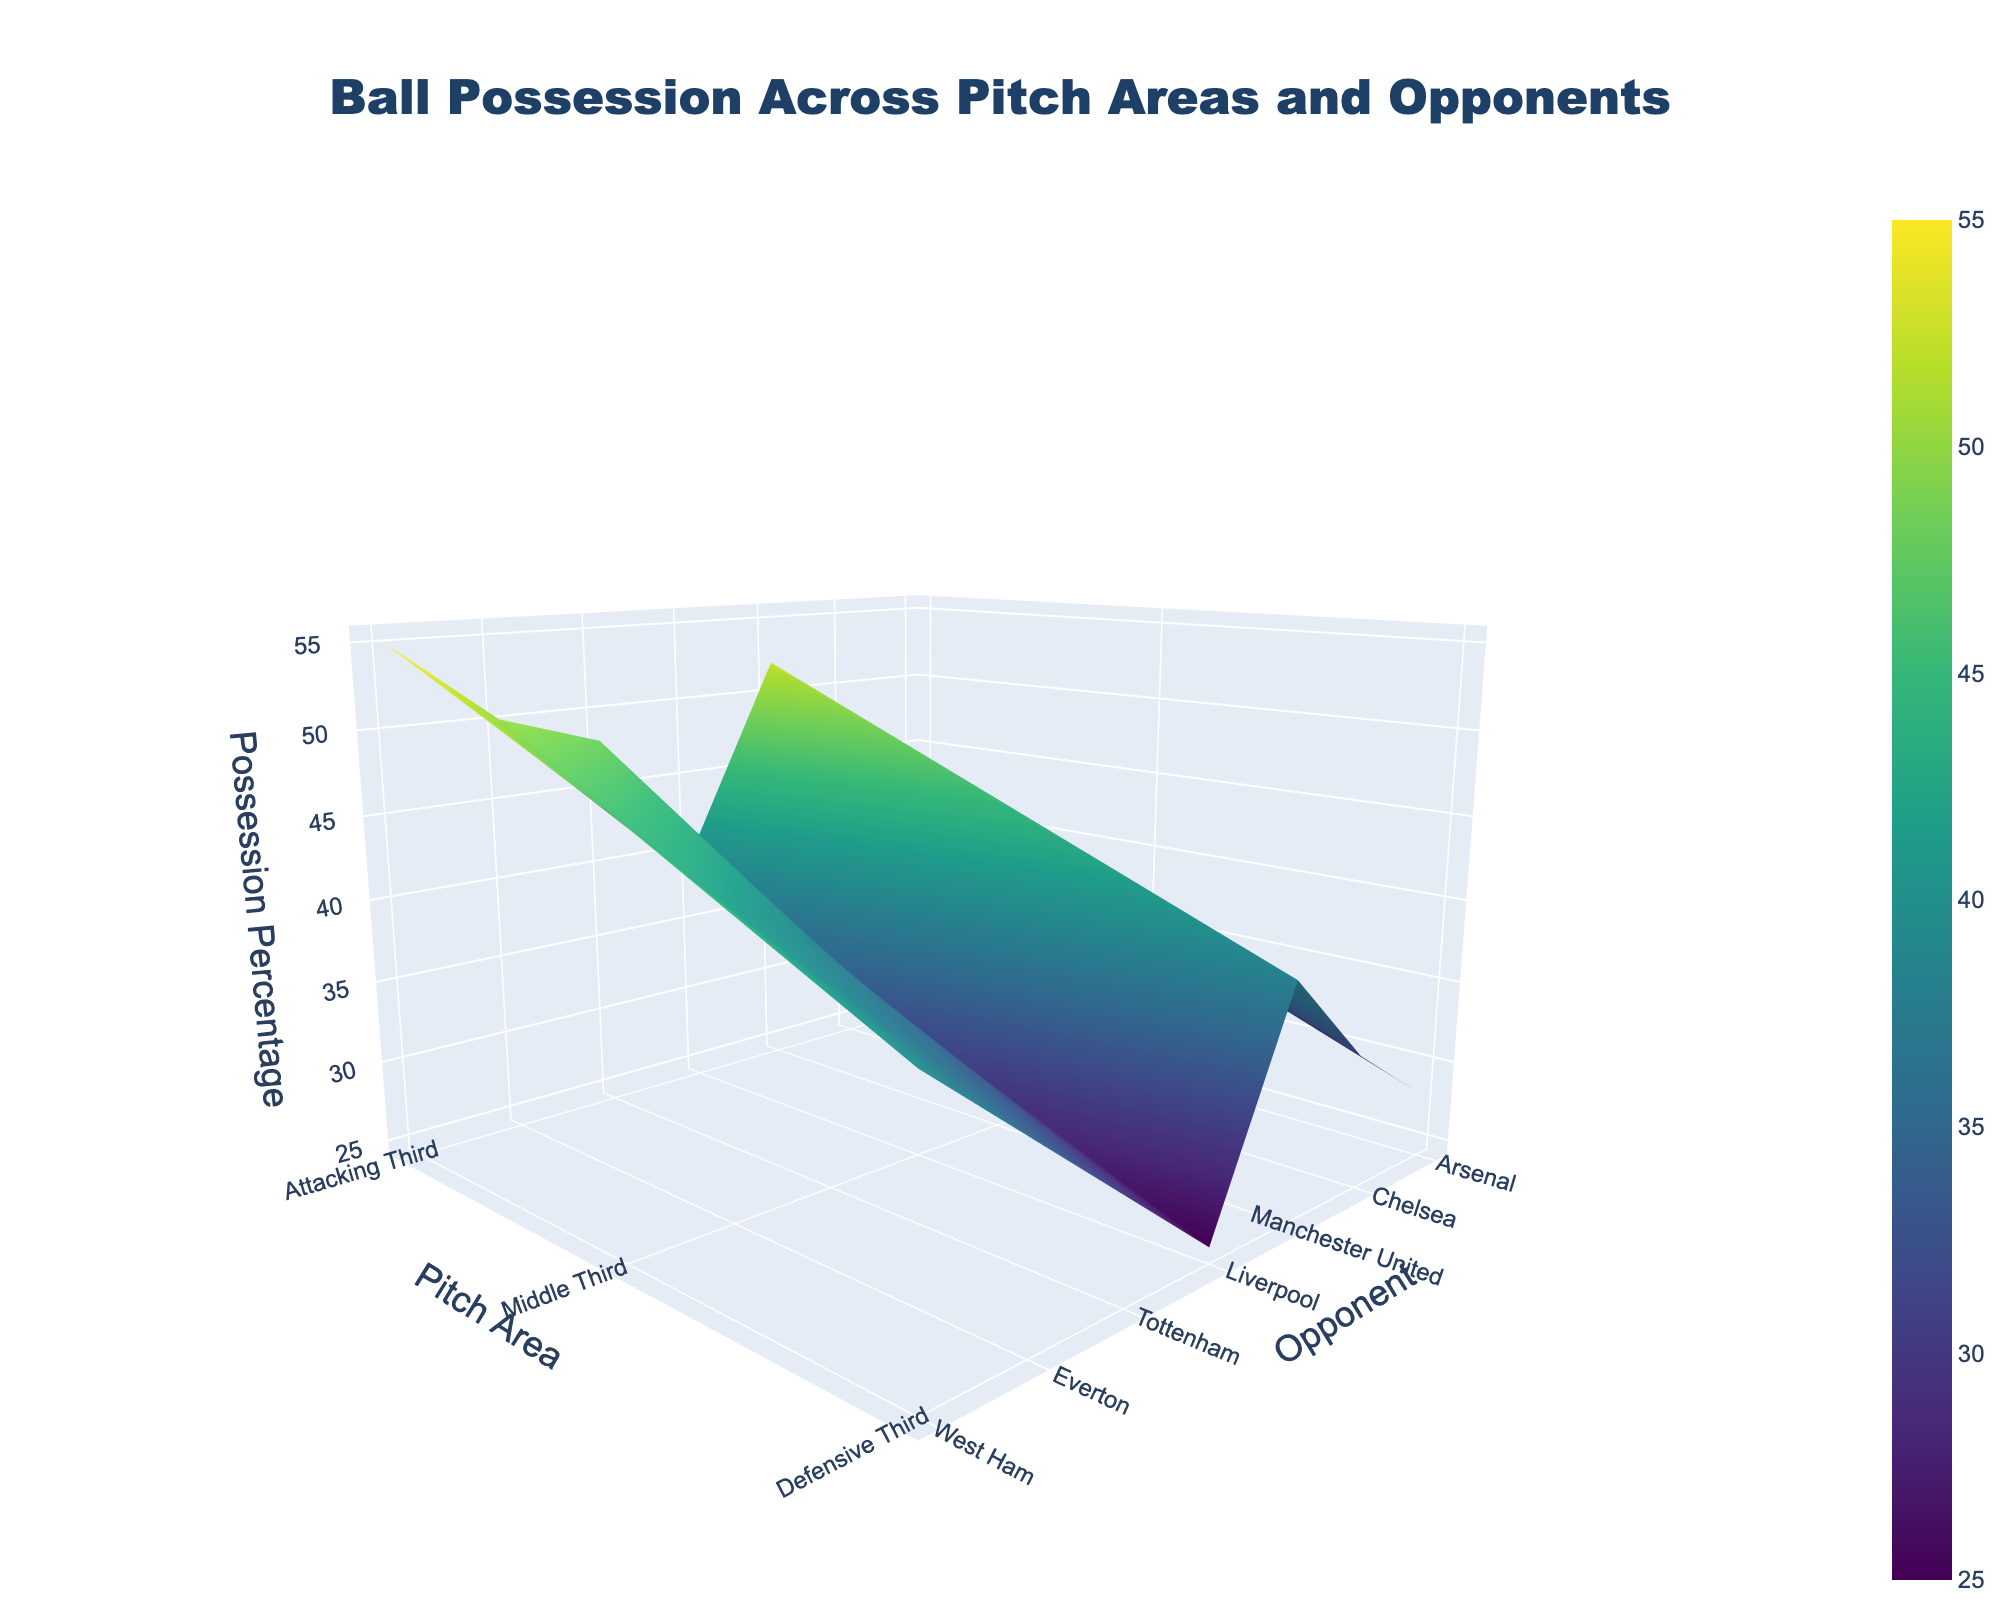How does ball possession in the middle third against Arsenal compare to that against Chelsea? To answer this, refer to the section of the 3D surface plot for the middle third and locate the possession percentages for Arsenal and Chelsea. For Arsenal, the possession percentage in the middle third is 42%, while for Chelsea it's 45%. Compare these two values directly.
Answer: Chelsea has a higher possession percentage in the middle third than Arsenal Which opponent has the highest possession percentage in the middle third of the pitch? Look for the tallest peak in the middle third section of the plot. Identify the highest value of possession percentage. For the middle third, the highest possession percentage is against West Ham, which is 55%.
Answer: West Ham Between which opponents does the team have the least variation in ball possession in the attacking third? Check the possession percentages for the attacking third across various opponents and identify the smallest range between the highest and lowest figures. The variation between Arsenal (28%) and Manchester United (30%) is the smallest, with a 2% difference.
Answer: Arsenal and Manchester United What is the average possession percentage in the defensive third across all opponents? Sum up the possession percentages in the defensive third for all opponents and divide by the number of opponents. The numbers are 35, 40, 38, 32, 42, 45, and 48. The sum is (35 + 40 + 38 + 32 + 42 + 45 + 48) = 280. There are 7 opponents, so the average is 280/7.
Answer: 40% Is the possession percentage in the attacking third higher against Tottenham or Liverpool? Locate the attacking third section of the plot and compare the possession percentages for Tottenham and Liverpool. Tottenham's possession percentage in the attacking third is 35%, while Liverpool's is 25%.
Answer: Tottenham How does the possession percentage in the middle third compare between the highest and lowest values recorded? Identify the highest and lowest possession percentages in the middle third by scanning the plot. The highest value is 55% (West Ham) and the lowest value is 40% (Liverpool). The difference between these values is 55 - 40.
Answer: 15% What is the general trend in possession percentage as the team progresses from the defensive third to the attacking third? Observe the surface gradient from the defensive third, through the middle third, to the attacking third. It generally decreases from the defensive third to the attacking third. For most opponents, higher possession is in the defensive and middle thirds, with a drop in the attacking third.
Answer: Possession decreases Who has the lowest possession percentage in the attacking third? Identify the lowest point in the attacking third. Liverpool has the lowest possession percentage in the attacking third, which is 25%.
Answer: Liverpool Considering the overall possession across all thirds, which opponent has the most balanced possession (least variation)? Examine the possession percentages for each opponent across all thirds and look for the smallest range between the highest and lowest figures. Chelsea has 40% in the defensive third, 45% in the middle third, and 32% in the attacking third. The variation is within 13%, which is relatively balanced.
Answer: Chelsea What is the average possession percentage in the attacking third for opponents where the possession is above 30%? Calculate for opponents whose possession in the attacking third exceeds 30%. The relevant percentages are for Chelsea (32%), Manchester United (30%), Tottenham (35%), Everton (38%), and West Ham (40%). Sum these percentages (32 + 30 + 35 + 38 + 40) = 175, and divide by the number of relevant opponents (5).
Answer: 35% 